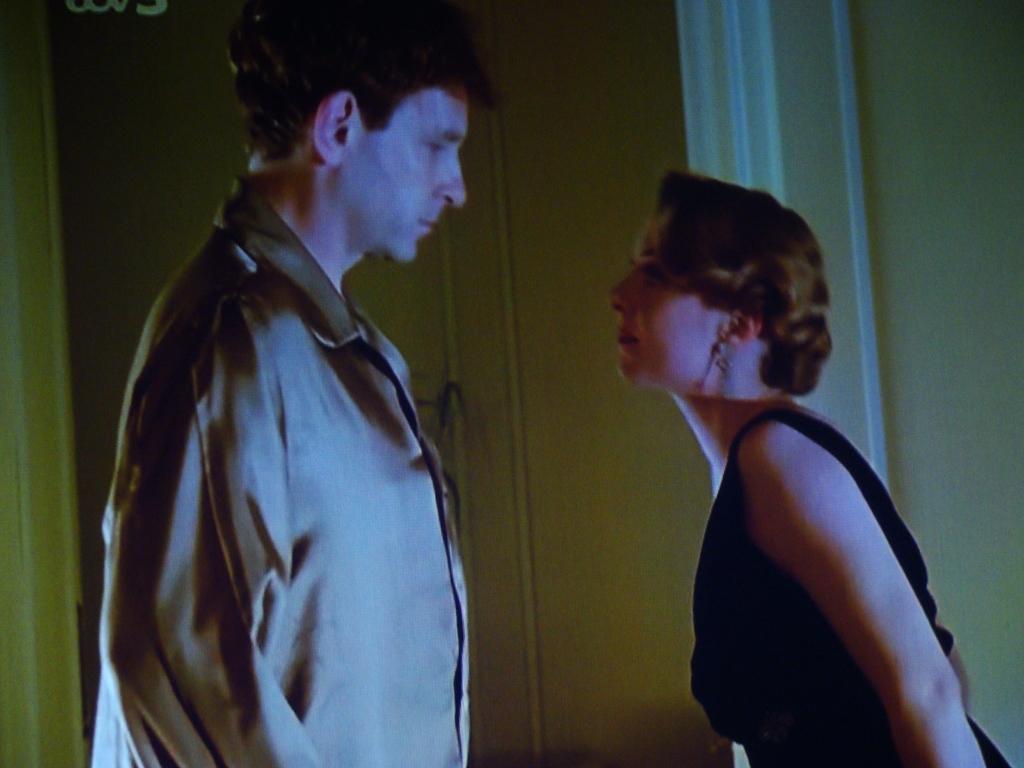Describe this image in one or two sentences. In this picture we can see a man standing and woman looking at each other and woman wore a black dress and a man wore a coat and in background we can see a wall, pillar. This woman has a short hair. 